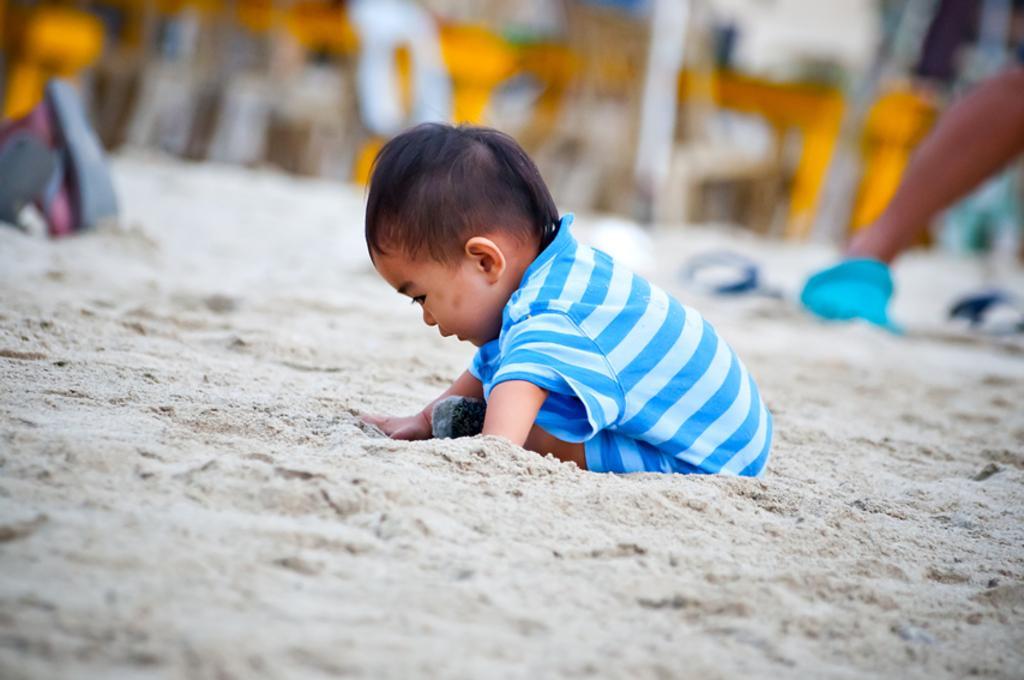Could you give a brief overview of what you see in this image? In the center of the picture there is a kid playing in the sand. The background is blurred. 